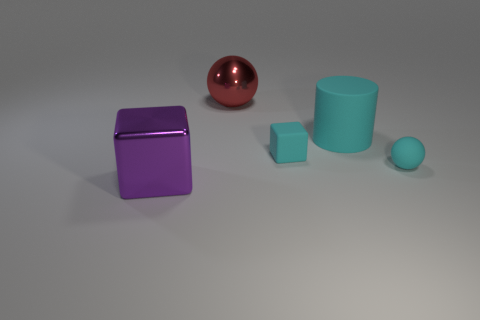Add 2 cyan balls. How many objects exist? 7 Subtract all cyan cubes. How many cubes are left? 1 Subtract 1 cubes. How many cubes are left? 1 Subtract all cylinders. How many objects are left? 4 Subtract all big cyan things. Subtract all small rubber objects. How many objects are left? 2 Add 4 purple cubes. How many purple cubes are left? 5 Add 4 red things. How many red things exist? 5 Subtract 1 purple cubes. How many objects are left? 4 Subtract all gray cylinders. Subtract all yellow blocks. How many cylinders are left? 1 